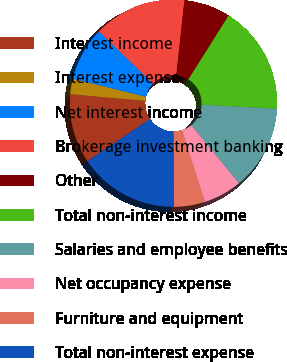Convert chart. <chart><loc_0><loc_0><loc_500><loc_500><pie_chart><fcel>Interest income<fcel>Interest expense<fcel>Net interest income<fcel>Brokerage investment banking<fcel>Other<fcel>Total non-interest income<fcel>Salaries and employee benefits<fcel>Net occupancy expense<fcel>Furniture and equipment<fcel>Total non-interest expense<nl><fcel>10.84%<fcel>2.41%<fcel>8.43%<fcel>14.46%<fcel>7.23%<fcel>16.87%<fcel>13.25%<fcel>6.02%<fcel>4.82%<fcel>15.66%<nl></chart> 